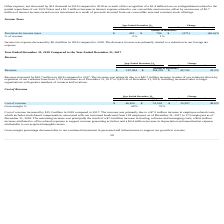According to Everbridge's financial document, What was the increase in the cost of revenue in 2018? According to the financial document, $15.3 million. The relevant text states: "Cost of revenue increased by $15.3 million in 2018 compared to 2017. The increase was primarily due to a $7.2 million increase in employee-rela..." Also, What was the cost of revenue in 2018 and 2019? The document shows two values: 46,810 and 31,503 (in thousands). From the document: "Cost of revenue $ 46,810 $ 31,503 $ 15,307 48.6% Cost of revenue $ 46,810 $ 31,503 $ 15,307 48.6%..." Also, What caused the decrease in gross margin percentage? due to our continued investment in personnel and infrastructure to support our growth in revenue.. The document states: "Gross margin percentage decreased due to our continued investment in personnel and infrastructure to support our growth in revenue...." Also, can you calculate: What is the average cost of revenue for 2018 and 2019? To answer this question, I need to perform calculations using the financial data. The calculation is: (46,810 + 31,503) / 2, which equals 39156.5 (in thousands). This is based on the information: "Cost of revenue $ 46,810 $ 31,503 $ 15,307 48.6% Cost of revenue $ 46,810 $ 31,503 $ 15,307 48.6%..." The key data points involved are: 31,503, 46,810. Additionally, In which year was cost of revenue less than 40,000 thousands? According to the financial document, 2017. The relevant text states: "2018 2017 $ %..." Also, can you calculate: What is the change in the gross margin between 2018 and 2019? Based on the calculation: 68 - 70, the result is -2 (percentage). This is based on the information: "Gross margin % 68% 70% Gross margin % 68% 70%..." The key data points involved are: 68, 70. 